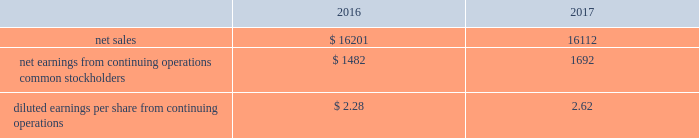Pro forma financial information the following pro forma consolidated condensed financial results of operations are presented as if the acquisition of the valves & controls business occurred on october 1 , 2015 .
The pro forma information is presented for informational purposes only and is not indicative of the results of operations that would have been achieved had the acquisition occurred as of that time. .
The pro forma results for 2016 were adjusted to include first year acquisition accounting charges related to inventory and backlog of $ 122 in 2017 .
The pro forma 2016 results also include acquisition costs of $ 52 , while the 2017 pro forma results were adjusted to exclude these charges .
On october 2 , 2017 , the company sold its residential storage business for $ 200 in cash , subject to post-closing adjustments , and expects to recognize a loss of approximately $ 40 in 2018 due to income taxes resulting from nondeductible goodwill .
The company expects to realize approximately $ 140 in after-tax cash proceeds from the sale .
This business , with sales of $ 298 and pretax earnings of $ 15 in 2017 , is a leader in home organization and storage systems , and was reported within the tools & home products segment .
Assets and liabilities were classified as held-for-sale as of september 30 , 2017 .
The company acquired six businesses in 2016 , four in automation solutions and two in climate technologies .
Total cash paid for these businesses was $ 132 , net of cash acquired .
Annualized sales for these businesses were approximately $ 51 in 2016 .
The company recognized goodwill of $ 83 ( $ 27 of which is expected to be tax deductible ) and other identifiable intangible assets of $ 50 , primarily customer relationships and intellectual property with a weighted-average life of approximately nine years .
The company completed eight acquisitions in 2015 , seven in automation solutions and one in tools & home products , which had combined annualized sales of approximately $ 115 .
Total cash paid for all businesses was $ 324 , net of cash acquired .
The company recognized goodwill of $ 178 ( $ 42 of which is expected to be tax deductible ) and other intangible assets of $ 128 , primarily customer relationships and intellectual property with a weighted-average life of approximately ten years .
In january 2015 , the company completed the sale of its mechanical power transmission solutions business for $ 1.4 billion , and recognized a pretax gain from the transaction of $ 939 ( $ 532 after-tax , $ 0.78 per share ) .
Assets and liabilities sold were as follows : current assets , $ 182 ( accounts receivable , inventories , other current assets ) ; other assets , $ 374 ( property , plant and equipment , goodwill , other noncurrent assets ) ; accrued expenses , $ 56 ( accounts payable , other current liabilities ) ; and other liabilities , $ 41 .
Proceeds from the divestiture were used for share repurchase .
This business was previously reported in the former industrial automation segment , and had partial year sales in 2015 of $ 189 and related pretax earnings of $ 21 .
Power transmission solutions designs and manufactures market-leading couplings , bearings , conveying components and gearing and drive components , and provides supporting services and solutions .
On september 30 , 2015 , the company sold its intermetro commercial storage business for $ 411 in cash and recognized a pretax gain from the transaction of $ 100 ( $ 79 after-tax , $ 0.12 per share ) .
This business had annual sales of $ 288 and pretax earnings of $ 42 in 2015 and was reported in the former commercial & residential solutions segment .
Assets and liabilities sold were as follows : current assets , $ 62 ( accounts receivable , inventories , other current assets ) ; other assets , $ 292 ( property , plant and equipment , goodwill , other noncurrent assets ) ; current liabilities , $ 34 ( accounts payable , other current liabilities ) ; and other liabilities , $ 9 .
Intermetro is a leading manufacturer and supplier of storage and transport products in the food service , commercial products and health care industries .
The results of operations of the acquired businesses discussed above have been included in the company 2019s consolidated results of operations since the respective dates of acquisition .
( 4 ) discontinued operations in 2017 , the company completed the previously announced strategic actions to streamline its portfolio and drive growth in its core businesses .
On november 30 , 2016 , the company completed the sale of its network power systems business for $ 4.0 billion in cash and retained a subordinated interest in distributions , contingent upon the equity holders first receiving a threshold return on their initial investment .
This business comprised the former network power segment .
Additionally , on january 31 , 2017 , the company completed the sale of its power generation , motors and drives business for approximately $ 1.2 billion , subject to post-closing .
What was the ratio of the price received for the residential storage sale of the business to the annual sales of the it? 
Computations: (200 / 298)
Answer: 0.67114. 